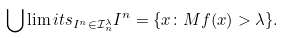Convert formula to latex. <formula><loc_0><loc_0><loc_500><loc_500>\bigcup \lim i t s _ { I ^ { n } \in \mathcal { I } _ { n } ^ { \lambda } } I ^ { n } = \{ x \colon M f ( x ) > \lambda \} .</formula> 